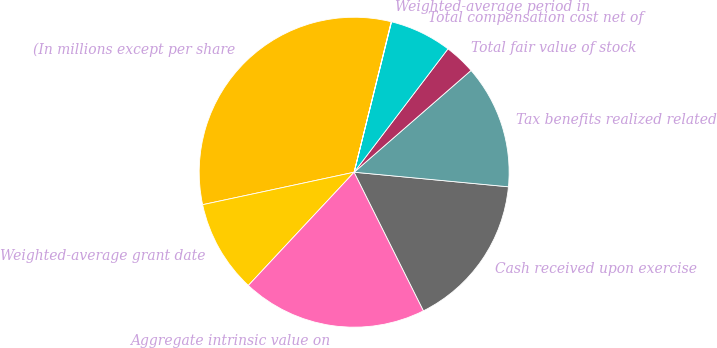<chart> <loc_0><loc_0><loc_500><loc_500><pie_chart><fcel>(In millions except per share<fcel>Weighted-average grant date<fcel>Aggregate intrinsic value on<fcel>Cash received upon exercise<fcel>Tax benefits realized related<fcel>Total fair value of stock<fcel>Total compensation cost net of<fcel>Weighted-average period in<nl><fcel>32.21%<fcel>9.68%<fcel>19.34%<fcel>16.12%<fcel>12.9%<fcel>3.25%<fcel>6.47%<fcel>0.03%<nl></chart> 